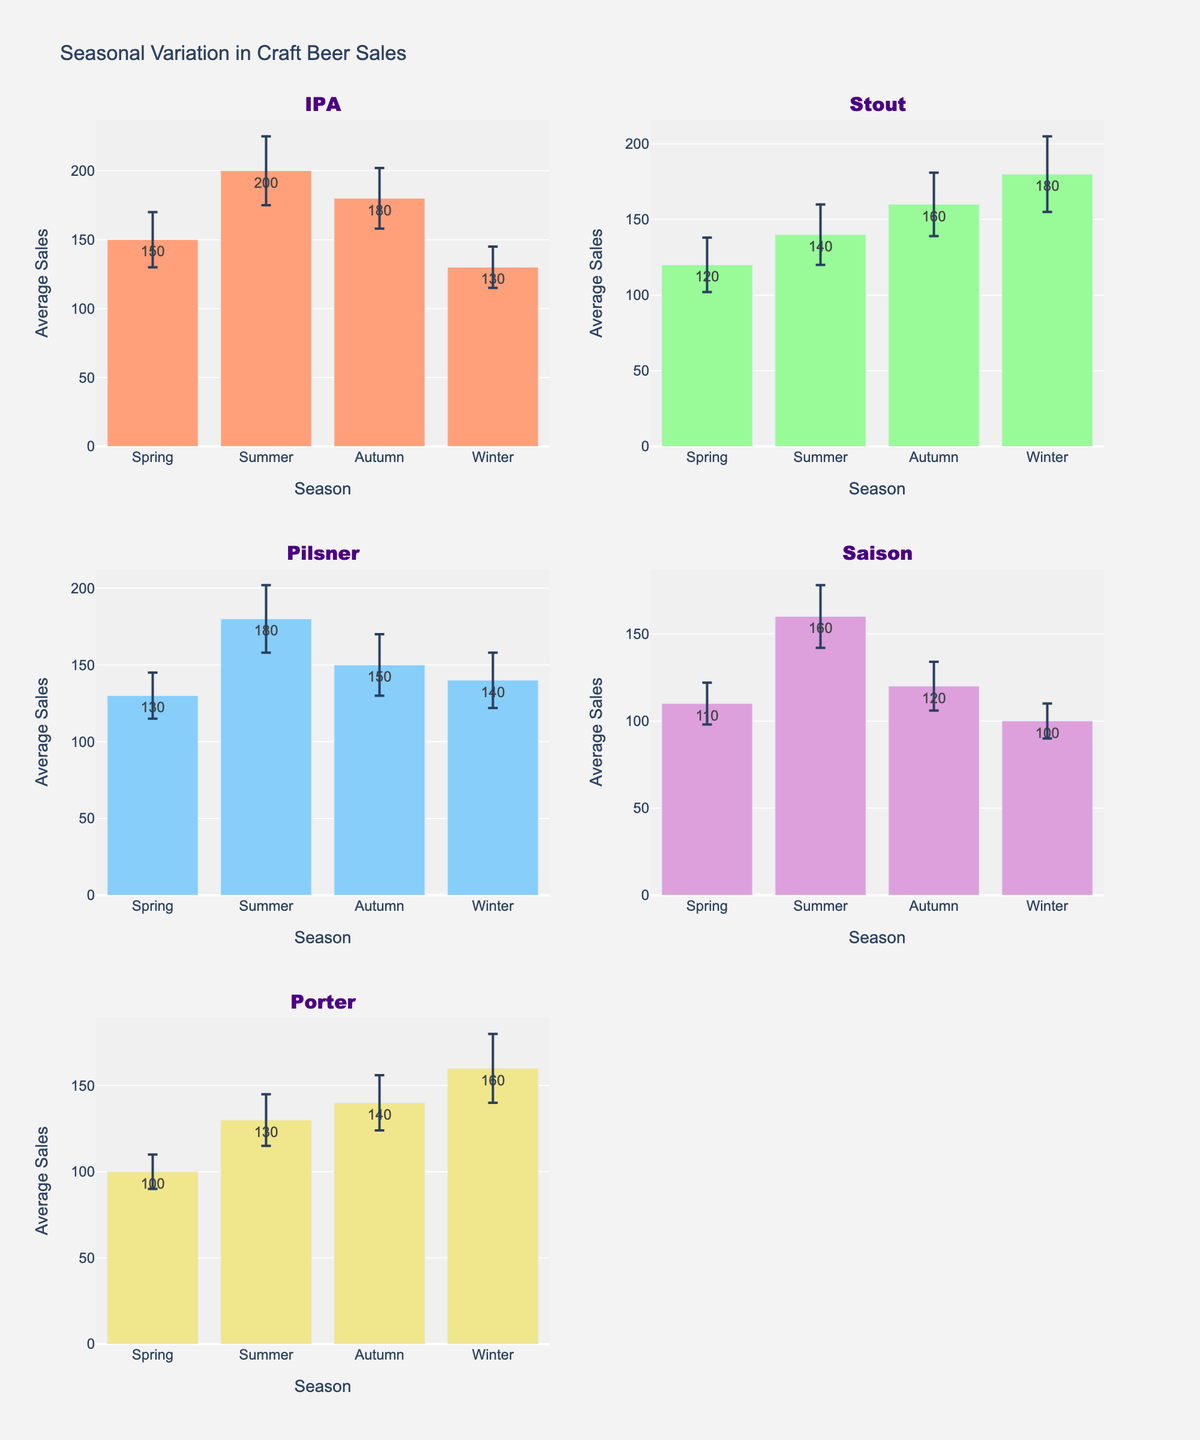Which season has the highest average sales for IPA? By looking at the subplot for IPA, the average sales for each season are shown. Summer has the highest bar, indicating the highest average sales.
Answer: Summer What is the average sales in Autumn for Porter? Referring to the subplot for Porter, the average sales in Autumn is visible. It's 140.
Answer: 140 Which beer type has the lowest average sales in Winter? Checking each subplot, the bar for Saison in Winter is the shortest among all Winter bars, indicating the lowest average sales.
Answer: Saison Which beer types have higher average sales in Summer compared to Autumn? Examine the heights of the bars for Summer and Autumn for each beer type:
- IPA has higher in Summer than Autumn (200 vs 180)
- Stout has lower in Summer than Autumn (140 vs 160)
- Pilsner has higher in Summer than Autumn (180 vs 150)
- Saison has higher in Summer than Autumn (160 vs 120)
- Porter has lower in Summer than Autumn (130 vs 140)
So IPA, Pilsner, and Saison have higher sales in Summer compared to Autumn.
Answer: IPA, Pilsner, Saison What is the difference in average sales between Summer and Winter for Stout? For Stout, in Summer the average sales are 140 and in Winter they are 180. The difference is 180 - 140 = 40.
Answer: 40 How consistent are Pilsner sales across seasons? To understand the consistency, compare the error bars (standard deviation) along with average sales:
- Spring: 130±15
- Summer: 180±22
- Autumn: 150±20
- Winter: 140±18
Despite some fluctuations in sales, the standard deviations do not vary drastically, indicating moderate consistency.
Answer: Moderately consistent Which season has the most significant variability in sales for any beer type? Variability can be determined by looking at the length of the error bars. Stout in Winter has the largest error bar (25), indicating the most significant variability.
Answer: Winter for Stout 